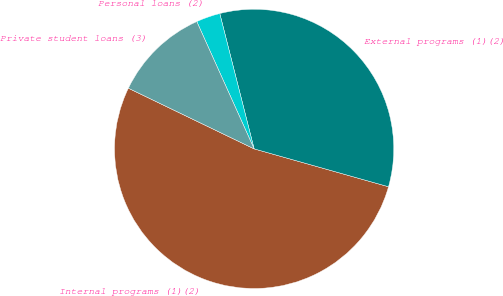<chart> <loc_0><loc_0><loc_500><loc_500><pie_chart><fcel>Internal programs (1)(2)<fcel>External programs (1)(2)<fcel>Personal loans (2)<fcel>Private student loans (3)<nl><fcel>52.78%<fcel>33.33%<fcel>2.78%<fcel>11.11%<nl></chart> 